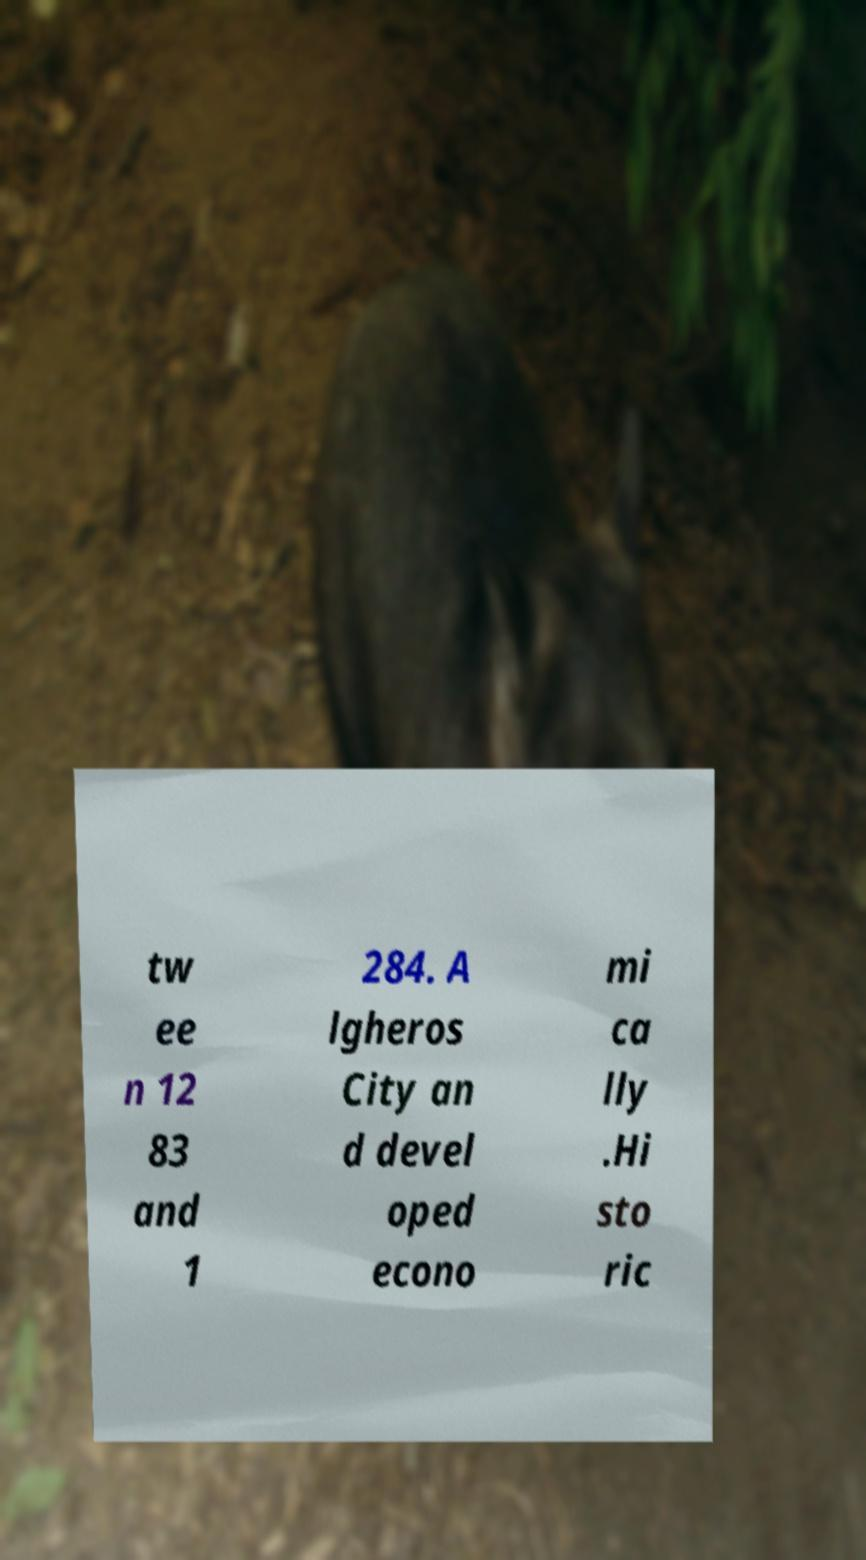Could you assist in decoding the text presented in this image and type it out clearly? tw ee n 12 83 and 1 284. A lgheros City an d devel oped econo mi ca lly .Hi sto ric 